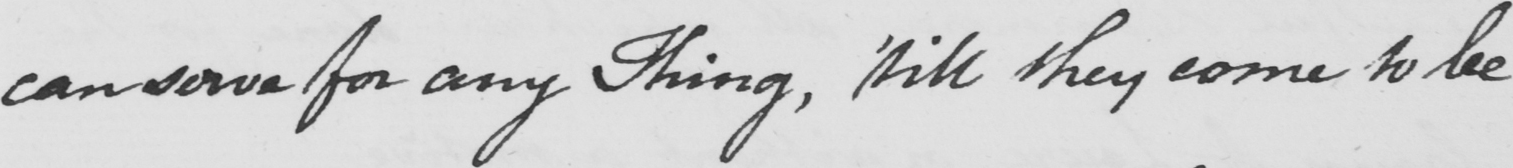What does this handwritten line say? can serve for any Thing , like they come to be 